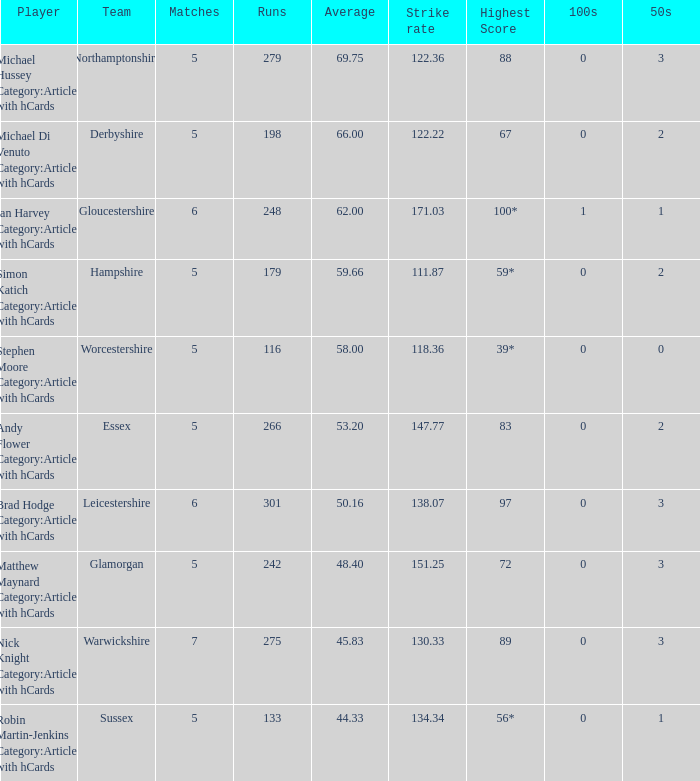What is the smallest amount of matches? 5.0. 